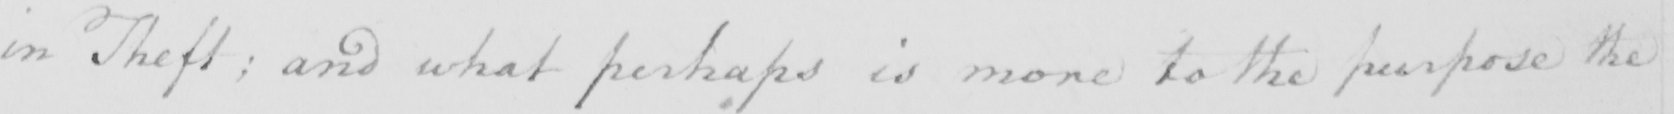Please provide the text content of this handwritten line. in theft ; and what perhaps is more to the purpose the 